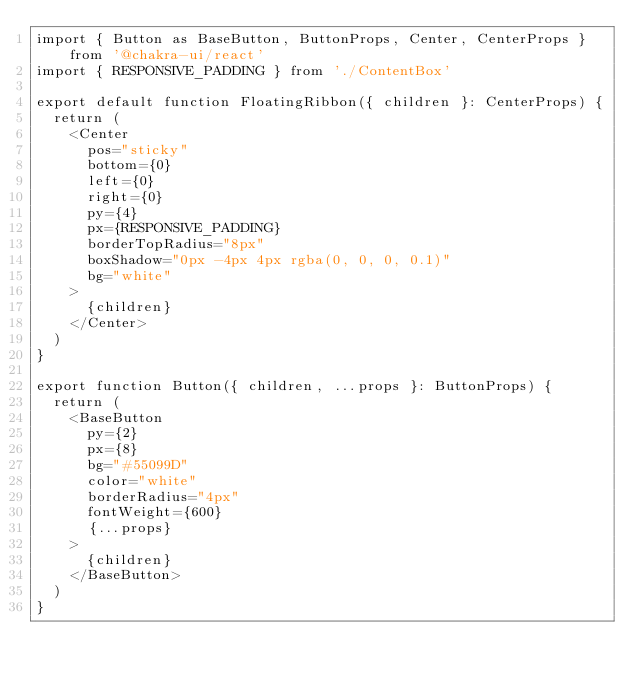<code> <loc_0><loc_0><loc_500><loc_500><_TypeScript_>import { Button as BaseButton, ButtonProps, Center, CenterProps } from '@chakra-ui/react'
import { RESPONSIVE_PADDING } from './ContentBox'

export default function FloatingRibbon({ children }: CenterProps) {
  return (
    <Center
      pos="sticky"
      bottom={0}
      left={0}
      right={0}
      py={4}
      px={RESPONSIVE_PADDING}
      borderTopRadius="8px"
      boxShadow="0px -4px 4px rgba(0, 0, 0, 0.1)"
      bg="white"
    >
      {children}
    </Center>
  )
}

export function Button({ children, ...props }: ButtonProps) {
  return (
    <BaseButton
      py={2}
      px={8}
      bg="#55099D"
      color="white"
      borderRadius="4px"
      fontWeight={600}
      {...props}
    >
      {children}
    </BaseButton>
  )
}
</code> 